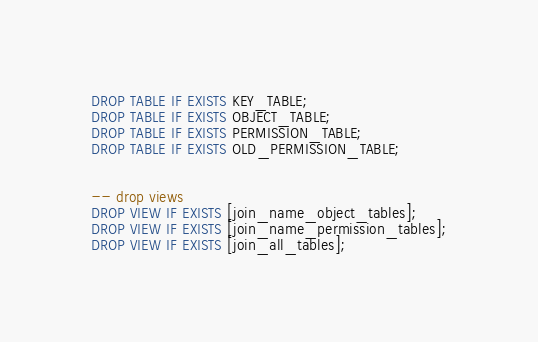Convert code to text. <code><loc_0><loc_0><loc_500><loc_500><_SQL_>DROP TABLE IF EXISTS KEY_TABLE;
DROP TABLE IF EXISTS OBJECT_TABLE;
DROP TABLE IF EXISTS PERMISSION_TABLE;
DROP TABLE IF EXISTS OLD_PERMISSION_TABLE;


-- drop views
DROP VIEW IF EXISTS [join_name_object_tables];
DROP VIEW IF EXISTS [join_name_permission_tables];
DROP VIEW IF EXISTS [join_all_tables];

</code> 